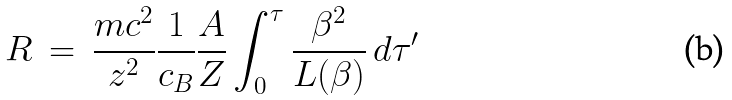<formula> <loc_0><loc_0><loc_500><loc_500>R \, = \, \frac { m c ^ { 2 } } { z ^ { 2 } } \frac { 1 } { c _ { B } } \frac { A } { Z } \int _ { 0 } ^ { \tau } \frac { \beta ^ { 2 } } { L ( \beta ) } \, d \tau ^ { \prime }</formula> 